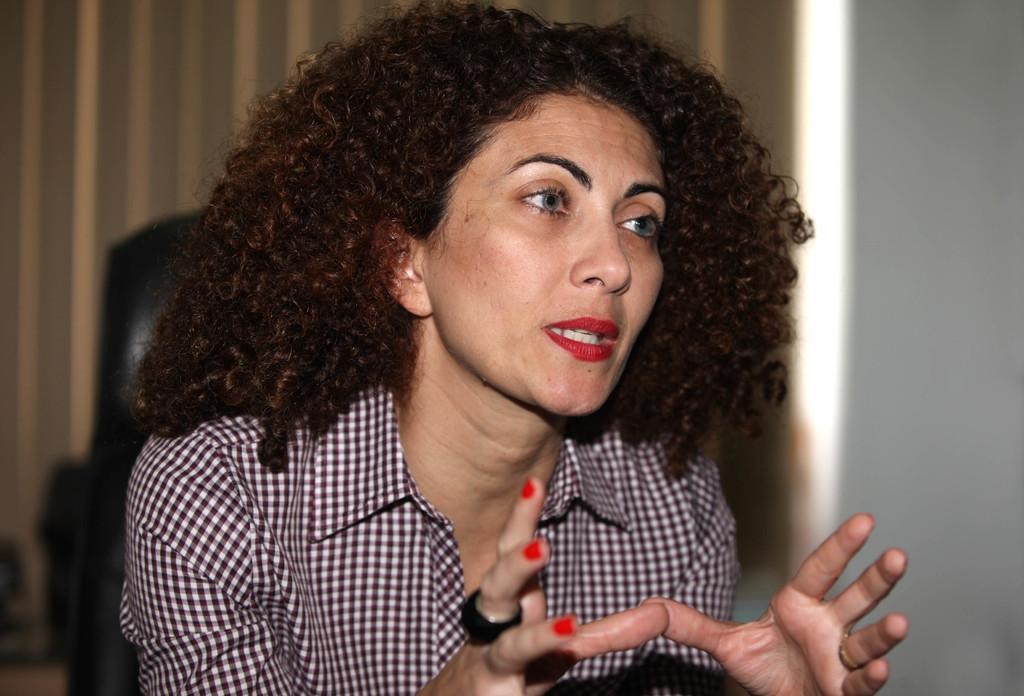In one or two sentences, can you explain what this image depicts? In this image we can see a woman wearing a shirt and a ring on her finger. In the background, we can see curtain. 